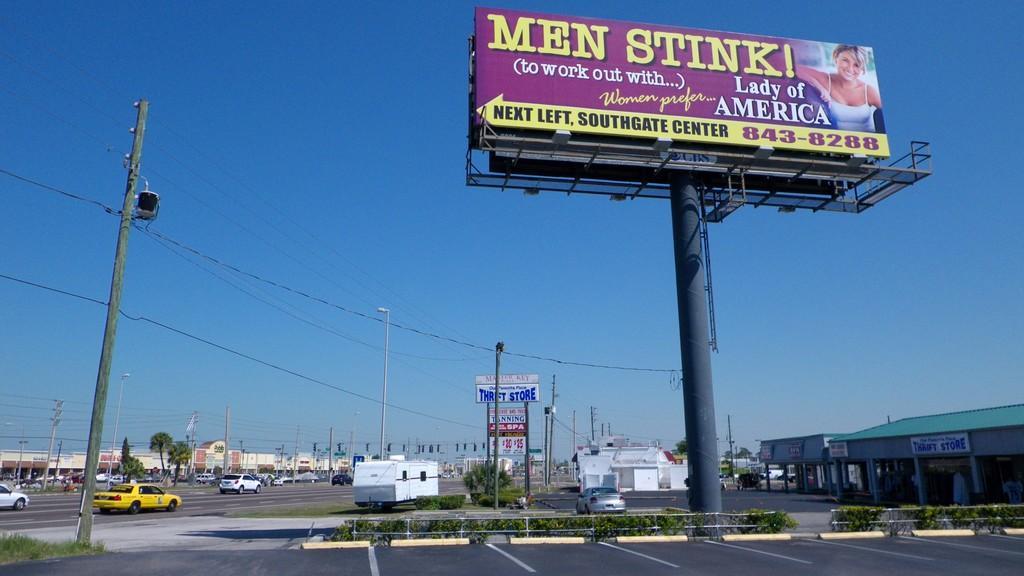Could you give a brief overview of what you see in this image? On the left side, there are vehicles on the road, there is a light, there are poles having cables, plants, footpath and grass. On the right side, there is a hoarding attached to the pole, there are buildings, vehicles, plants and a road. In the background, there are buildings, poles and there is blue sky. 